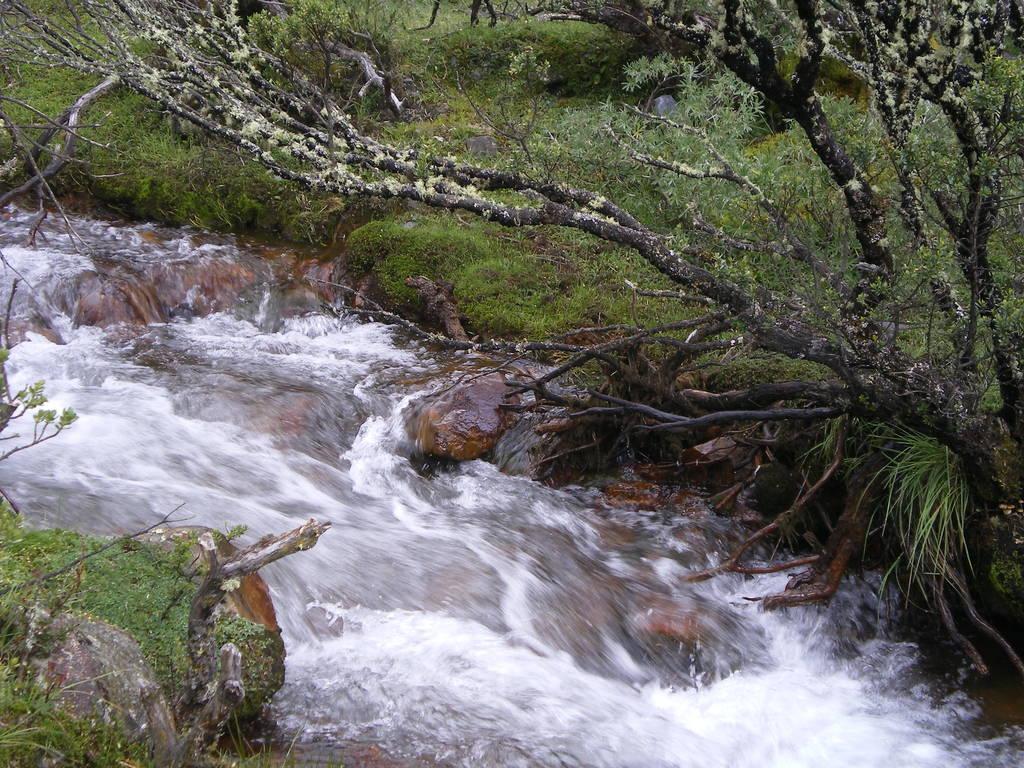How would you summarize this image in a sentence or two? In this image we can see water, group of rocks. In the background, we can see group of trees,plants and the grass. 